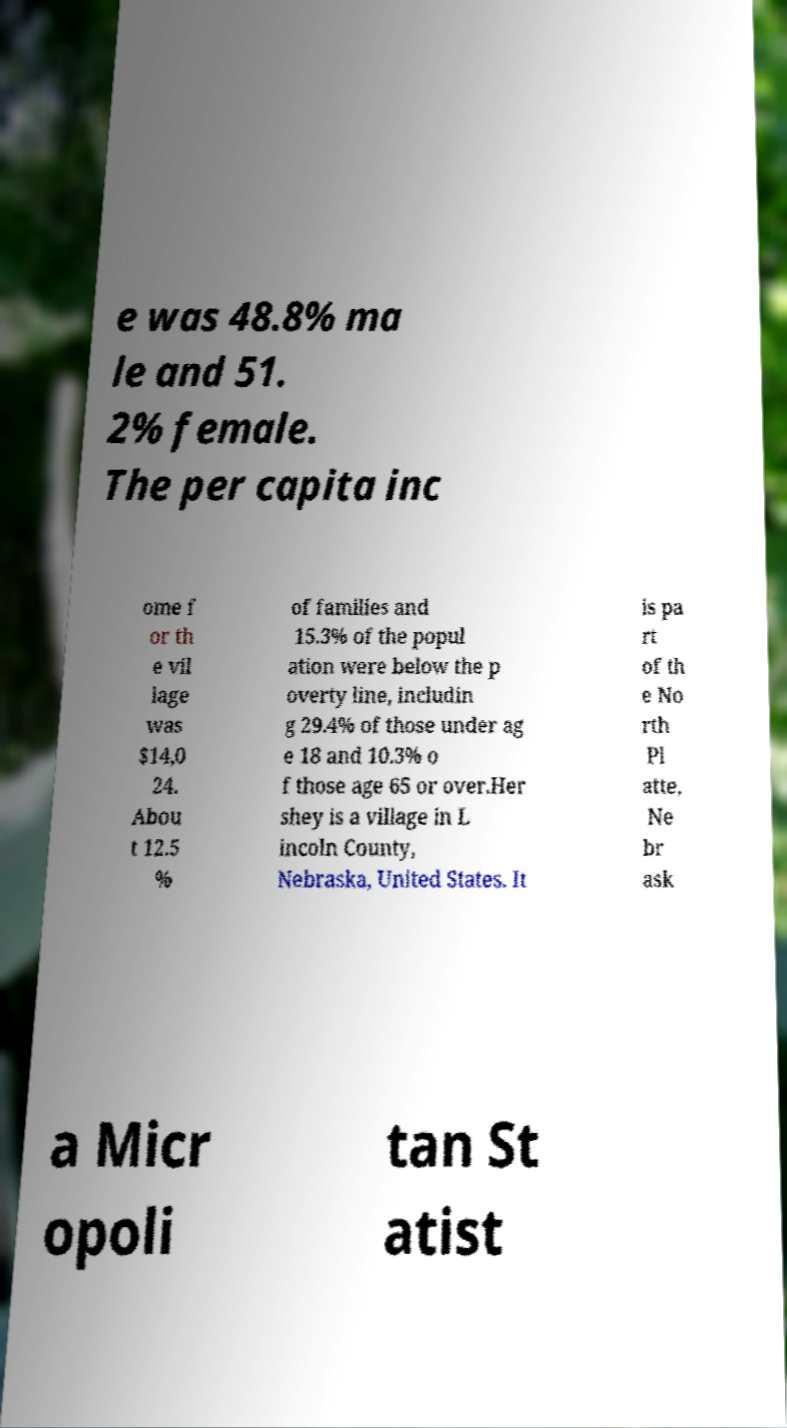Can you accurately transcribe the text from the provided image for me? e was 48.8% ma le and 51. 2% female. The per capita inc ome f or th e vil lage was $14,0 24. Abou t 12.5 % of families and 15.3% of the popul ation were below the p overty line, includin g 29.4% of those under ag e 18 and 10.3% o f those age 65 or over.Her shey is a village in L incoln County, Nebraska, United States. It is pa rt of th e No rth Pl atte, Ne br ask a Micr opoli tan St atist 